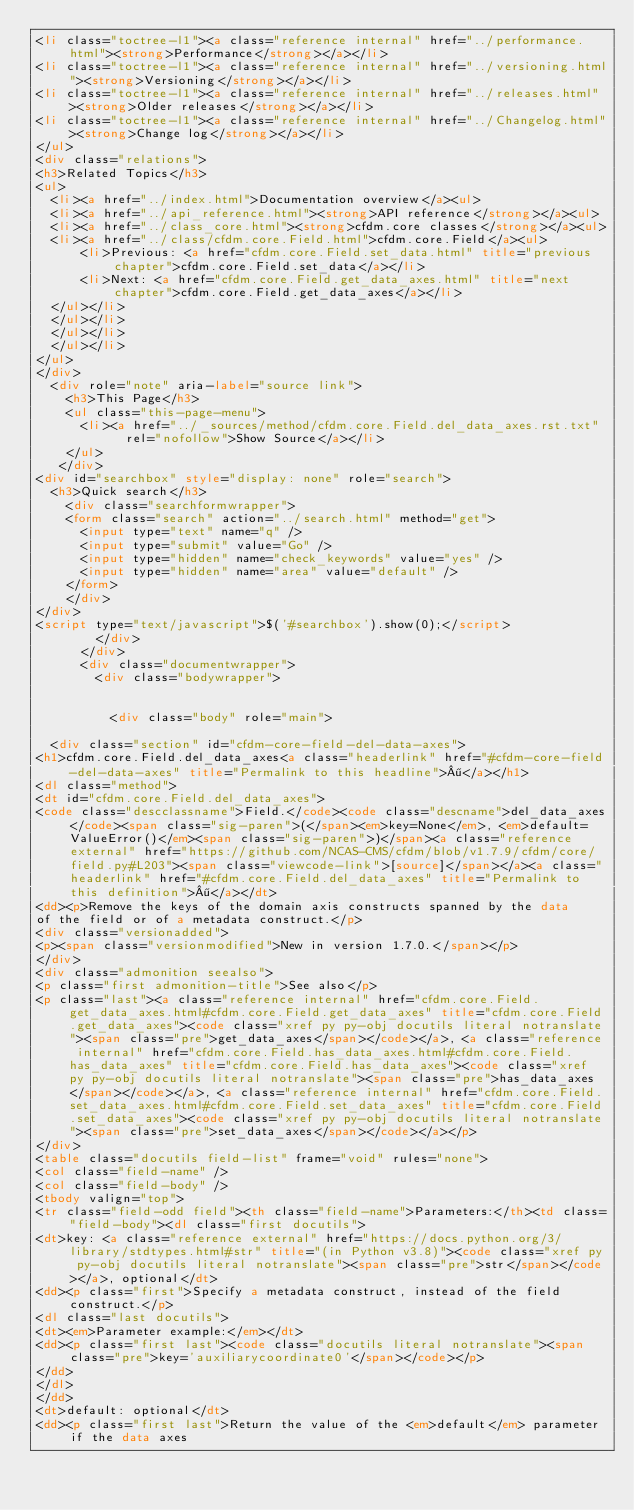Convert code to text. <code><loc_0><loc_0><loc_500><loc_500><_HTML_><li class="toctree-l1"><a class="reference internal" href="../performance.html"><strong>Performance</strong></a></li>
<li class="toctree-l1"><a class="reference internal" href="../versioning.html"><strong>Versioning</strong></a></li>
<li class="toctree-l1"><a class="reference internal" href="../releases.html"><strong>Older releases</strong></a></li>
<li class="toctree-l1"><a class="reference internal" href="../Changelog.html"><strong>Change log</strong></a></li>
</ul>
<div class="relations">
<h3>Related Topics</h3>
<ul>
  <li><a href="../index.html">Documentation overview</a><ul>
  <li><a href="../api_reference.html"><strong>API reference</strong></a><ul>
  <li><a href="../class_core.html"><strong>cfdm.core classes</strong></a><ul>
  <li><a href="../class/cfdm.core.Field.html">cfdm.core.Field</a><ul>
      <li>Previous: <a href="cfdm.core.Field.set_data.html" title="previous chapter">cfdm.core.Field.set_data</a></li>
      <li>Next: <a href="cfdm.core.Field.get_data_axes.html" title="next chapter">cfdm.core.Field.get_data_axes</a></li>
  </ul></li>
  </ul></li>
  </ul></li>
  </ul></li>
</ul>
</div>
  <div role="note" aria-label="source link">
    <h3>This Page</h3>
    <ul class="this-page-menu">
      <li><a href="../_sources/method/cfdm.core.Field.del_data_axes.rst.txt"
            rel="nofollow">Show Source</a></li>
    </ul>
   </div>
<div id="searchbox" style="display: none" role="search">
  <h3>Quick search</h3>
    <div class="searchformwrapper">
    <form class="search" action="../search.html" method="get">
      <input type="text" name="q" />
      <input type="submit" value="Go" />
      <input type="hidden" name="check_keywords" value="yes" />
      <input type="hidden" name="area" value="default" />
    </form>
    </div>
</div>
<script type="text/javascript">$('#searchbox').show(0);</script>
        </div>
      </div>
      <div class="documentwrapper">
        <div class="bodywrapper">
          

          <div class="body" role="main">
            
  <div class="section" id="cfdm-core-field-del-data-axes">
<h1>cfdm.core.Field.del_data_axes<a class="headerlink" href="#cfdm-core-field-del-data-axes" title="Permalink to this headline">¶</a></h1>
<dl class="method">
<dt id="cfdm.core.Field.del_data_axes">
<code class="descclassname">Field.</code><code class="descname">del_data_axes</code><span class="sig-paren">(</span><em>key=None</em>, <em>default=ValueError()</em><span class="sig-paren">)</span><a class="reference external" href="https://github.com/NCAS-CMS/cfdm/blob/v1.7.9/cfdm/core/field.py#L203"><span class="viewcode-link">[source]</span></a><a class="headerlink" href="#cfdm.core.Field.del_data_axes" title="Permalink to this definition">¶</a></dt>
<dd><p>Remove the keys of the domain axis constructs spanned by the data
of the field or of a metadata construct.</p>
<div class="versionadded">
<p><span class="versionmodified">New in version 1.7.0.</span></p>
</div>
<div class="admonition seealso">
<p class="first admonition-title">See also</p>
<p class="last"><a class="reference internal" href="cfdm.core.Field.get_data_axes.html#cfdm.core.Field.get_data_axes" title="cfdm.core.Field.get_data_axes"><code class="xref py py-obj docutils literal notranslate"><span class="pre">get_data_axes</span></code></a>, <a class="reference internal" href="cfdm.core.Field.has_data_axes.html#cfdm.core.Field.has_data_axes" title="cfdm.core.Field.has_data_axes"><code class="xref py py-obj docutils literal notranslate"><span class="pre">has_data_axes</span></code></a>, <a class="reference internal" href="cfdm.core.Field.set_data_axes.html#cfdm.core.Field.set_data_axes" title="cfdm.core.Field.set_data_axes"><code class="xref py py-obj docutils literal notranslate"><span class="pre">set_data_axes</span></code></a></p>
</div>
<table class="docutils field-list" frame="void" rules="none">
<col class="field-name" />
<col class="field-body" />
<tbody valign="top">
<tr class="field-odd field"><th class="field-name">Parameters:</th><td class="field-body"><dl class="first docutils">
<dt>key: <a class="reference external" href="https://docs.python.org/3/library/stdtypes.html#str" title="(in Python v3.8)"><code class="xref py py-obj docutils literal notranslate"><span class="pre">str</span></code></a>, optional</dt>
<dd><p class="first">Specify a metadata construct, instead of the field construct.</p>
<dl class="last docutils">
<dt><em>Parameter example:</em></dt>
<dd><p class="first last"><code class="docutils literal notranslate"><span class="pre">key='auxiliarycoordinate0'</span></code></p>
</dd>
</dl>
</dd>
<dt>default: optional</dt>
<dd><p class="first last">Return the value of the <em>default</em> parameter if the data axes</code> 